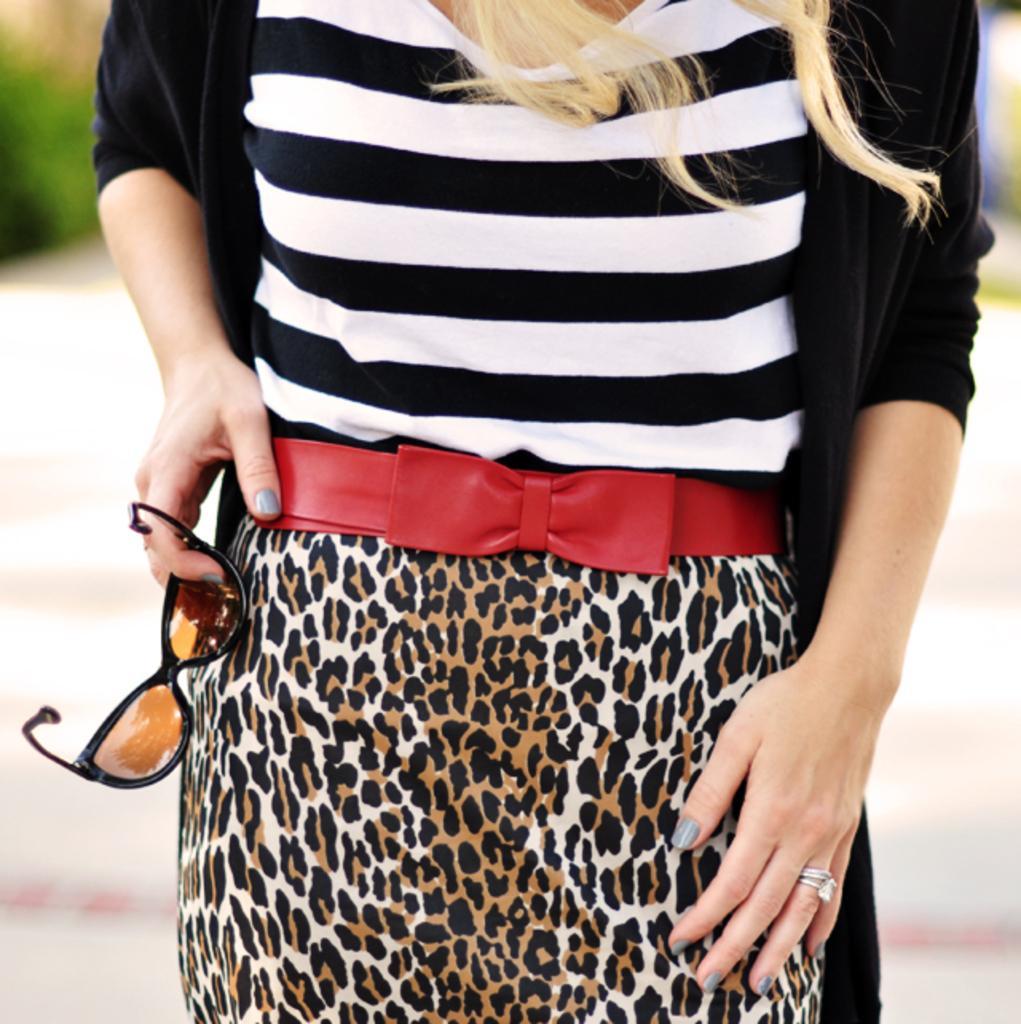Describe this image in one or two sentences. Here I can see a woman holding goggles in the hand and standing. She is wearing a black color jacket. The background is blurred. 